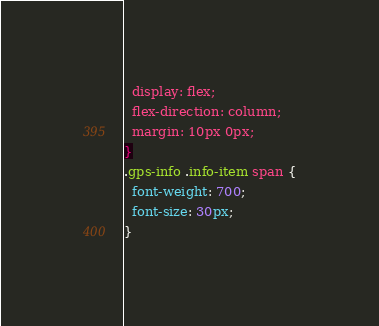<code> <loc_0><loc_0><loc_500><loc_500><_CSS_>  display: flex;
  flex-direction: column;
  margin: 10px 0px;
}
.gps-info .info-item span {
  font-weight: 700;
  font-size: 30px;
}</code> 